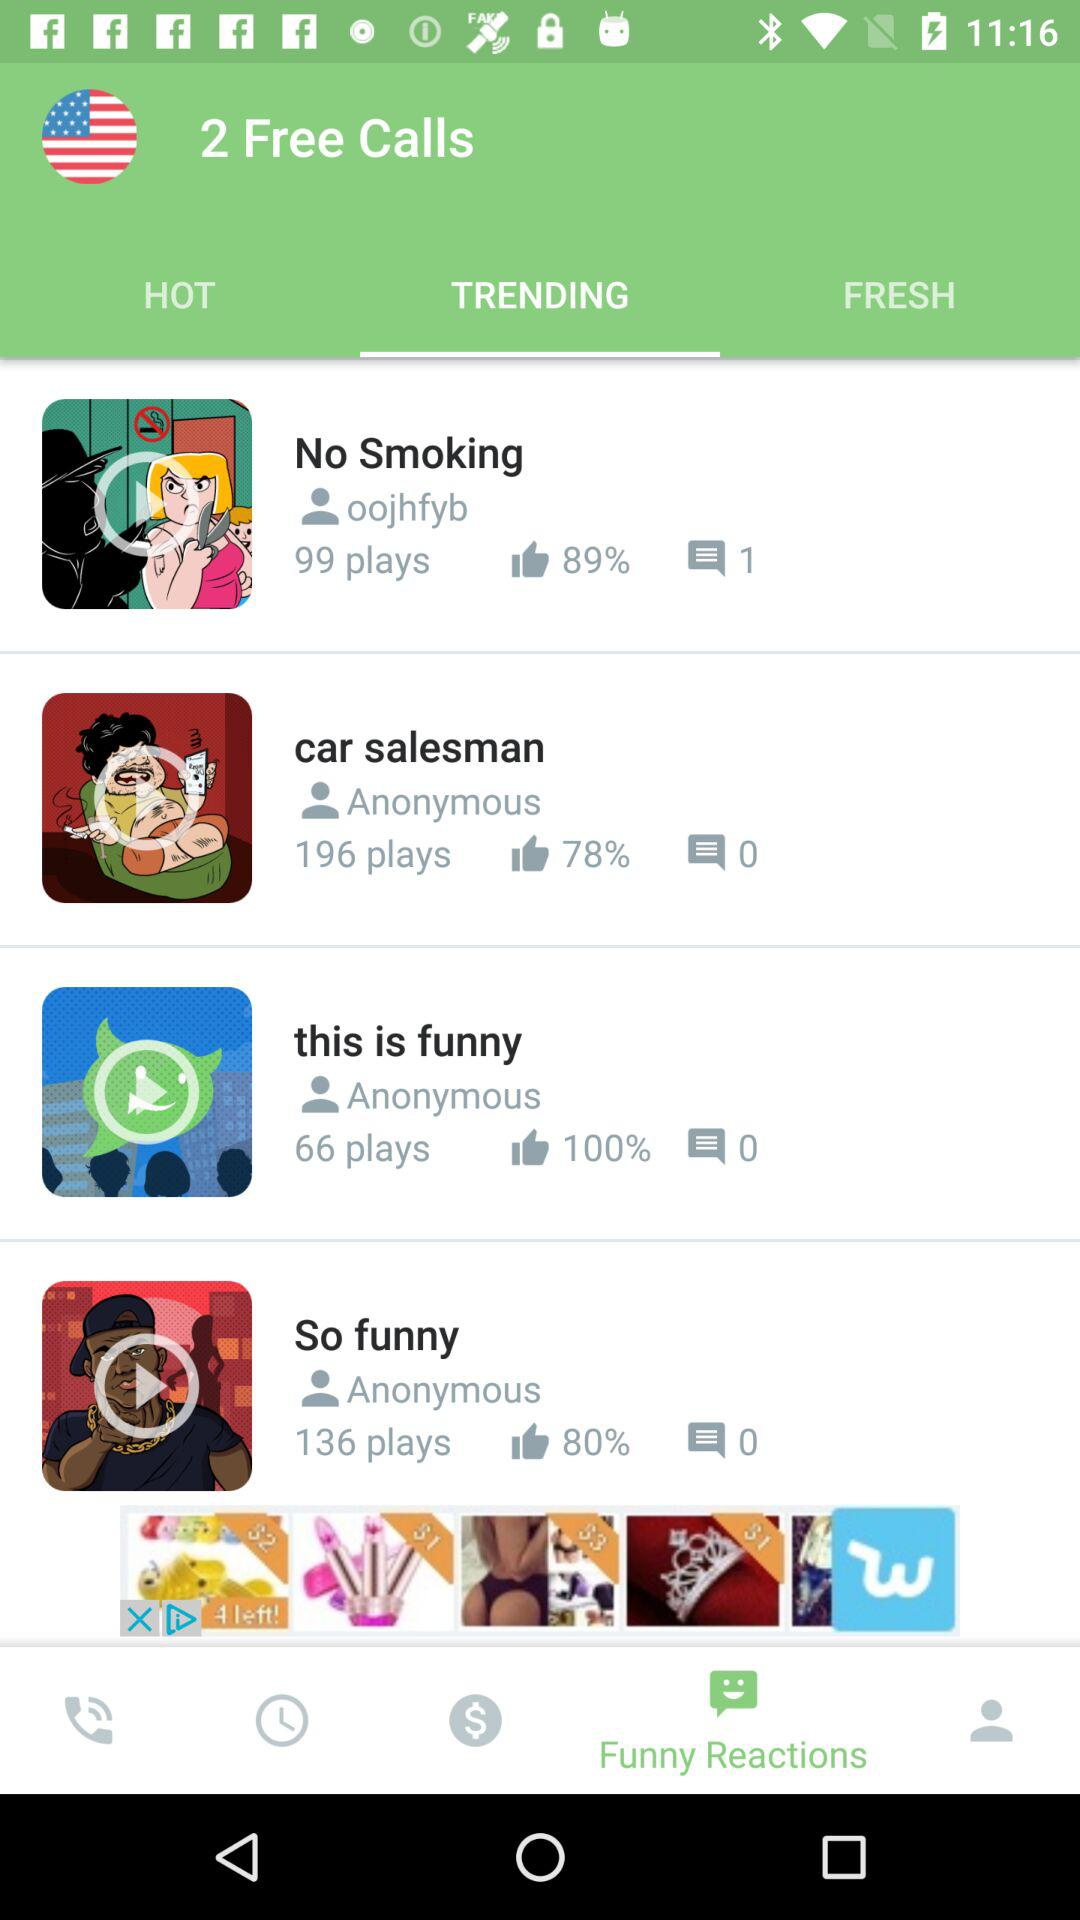What is the number of plays on the video "this is funny"? The number of plays is 66. 